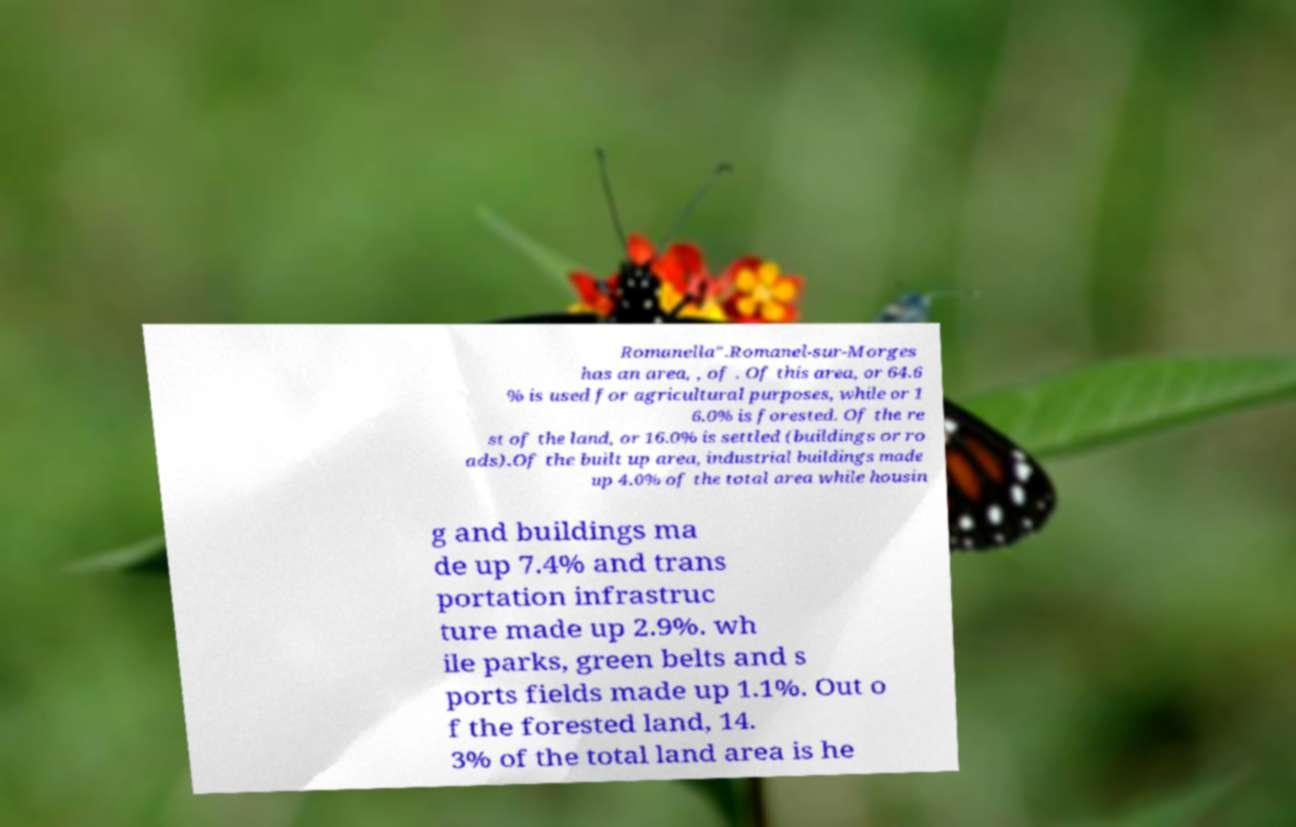Please identify and transcribe the text found in this image. Romanella".Romanel-sur-Morges has an area, , of . Of this area, or 64.6 % is used for agricultural purposes, while or 1 6.0% is forested. Of the re st of the land, or 16.0% is settled (buildings or ro ads).Of the built up area, industrial buildings made up 4.0% of the total area while housin g and buildings ma de up 7.4% and trans portation infrastruc ture made up 2.9%. wh ile parks, green belts and s ports fields made up 1.1%. Out o f the forested land, 14. 3% of the total land area is he 